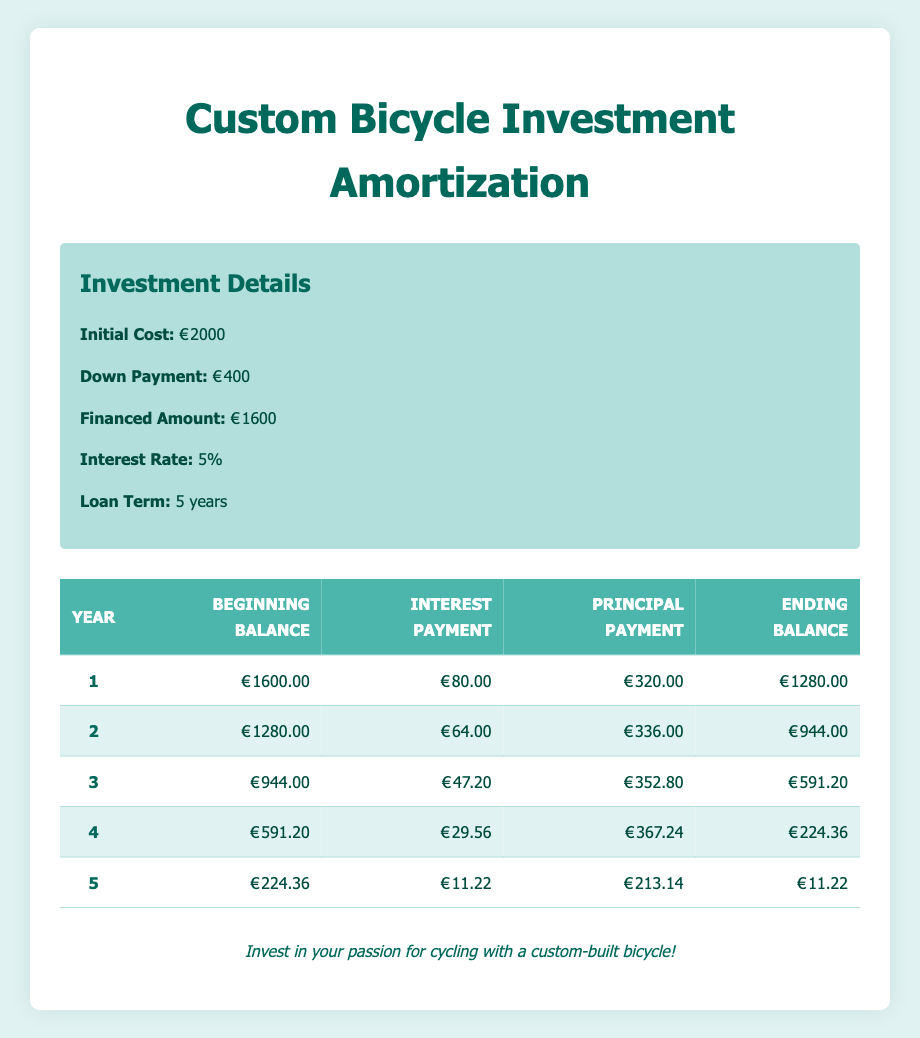What is the total interest paid over the entire loan term? To find the total interest paid, we sum up all the interest payments for each year: 80 + 64 + 47.2 + 29.56 + 11.22 = 232.98. Therefore, the total interest paid over the loan term is 232.98.
Answer: 232.98 What was the principal payment made in the third year? Referring to the table, the principal payment recorded in the third year is 352.80.
Answer: 352.80 Is the ending balance in year 5 equal to the interest payment in that year? The ending balance for year 5 is 11.22, while the interest payment for that year is also 11.22. Since they are equal, the statement is true.
Answer: Yes What is the remaining balance at the end of year 2? According to the table, the ending balance at the end of year 2 is 944.
Answer: 944 What is the average principal payment made over the five years? To obtain the average principal payment, we sum the principal payments: 320 + 336 + 352.8 + 367.24 + 213.14 = 1589.18. Dividing this sum by the number of years (5), we find the average principal payment is 1589.18 / 5 = 317.836.
Answer: 317.84 How much less was the interest payment made in year 4 compared to year 1? The interest payment in year 1 is 80, and the interest payment in year 4 is 29.56. The difference is calculated by subtracting year 4's interest payment from year 1's: 80 - 29.56 = 50.44.
Answer: 50.44 What was the total financed amount for the bicycle investment? The financed amount listed in the table is 1600. This is the amount that was borrowed to fund the custom-built bicycle.
Answer: 1600 How much principal was paid off from the beginning of the loan to the end of year 1? The principal payment in year 1 is 320. Thus, by the end of year 1, the total principal paid off is 320.
Answer: 320 What is the beginning balance for year 4? The beginning balance for year 4, as per the table, is 591.20.
Answer: 591.20 